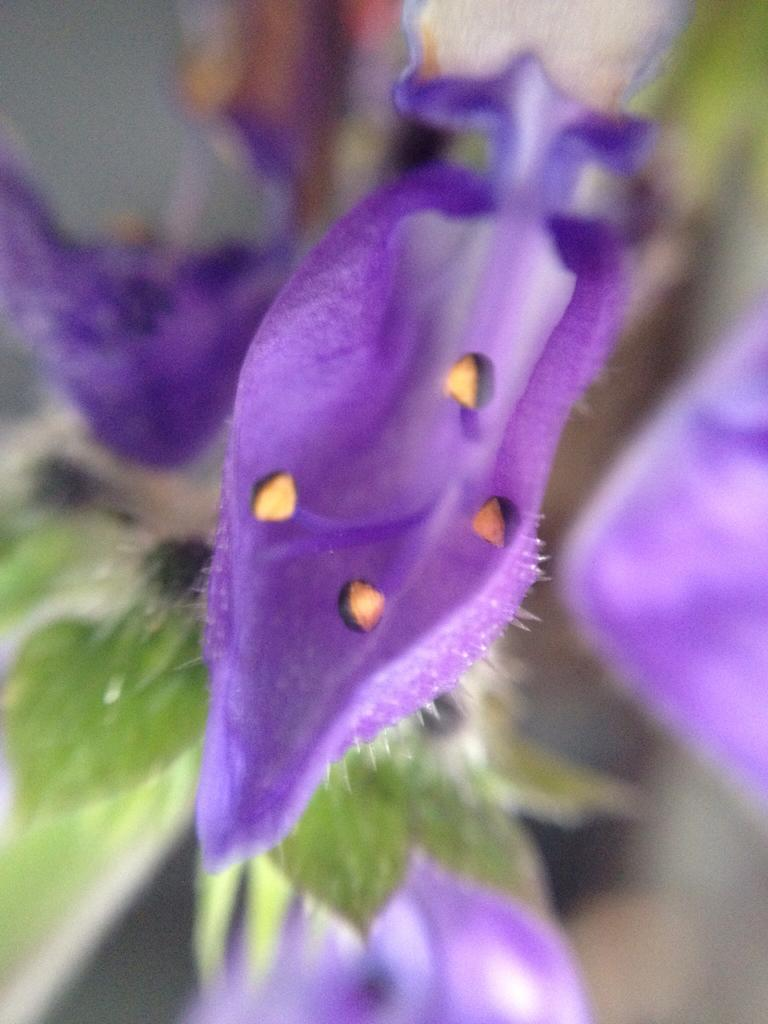What type of plants can be seen in the image? There are flowers and leaves in the image. Can you describe the specific parts of the plants that are visible? The flowers and leaves are the main parts of the plants that are visible in the image. Where is the basket located in the image? There is no basket present in the image. Can you tell me how many ducks are swimming in the image? There are no ducks present in the image. What is the condition of the throat of the flowers in the image? The flowers in the image do not have throats, as they are not living organisms with throats. 